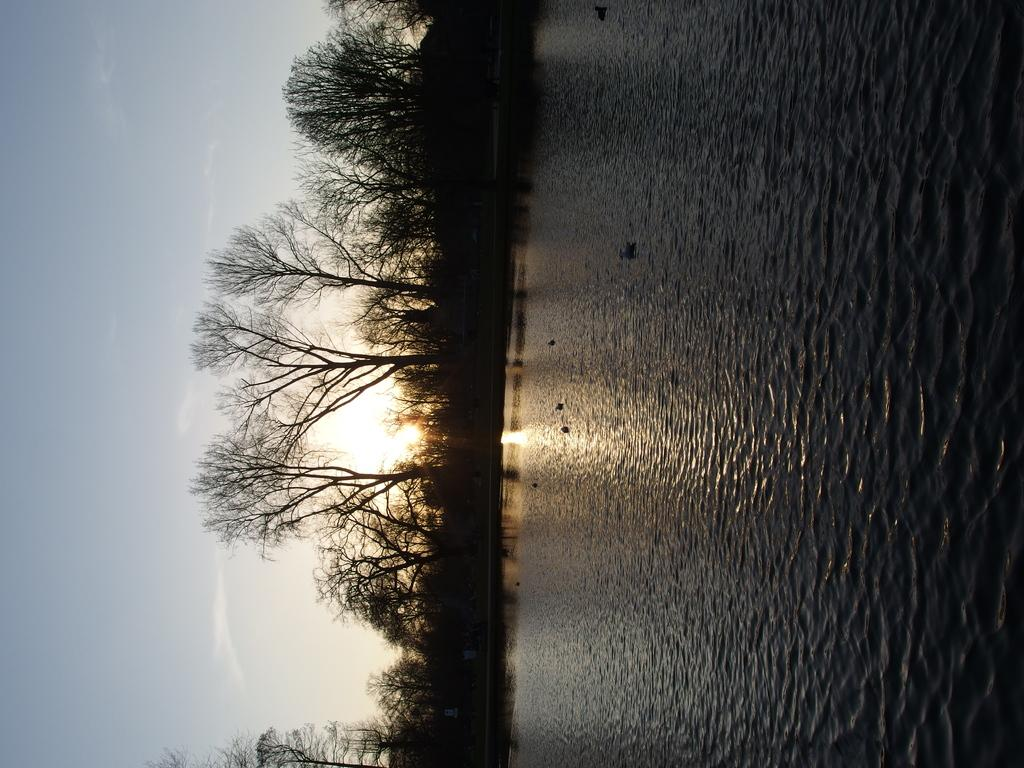Where was the picture taken? The picture was clicked outside. What can be seen on the right side of the image? There is a water body on the right side of the image. What is visible in the background of the image? The sky, sunlight, trees, and other objects are visible in the background of the image. What type of dinner is being served on the water body in the image? There is no dinner or any food visible in the image; it only features a water body and other elements in the background. 